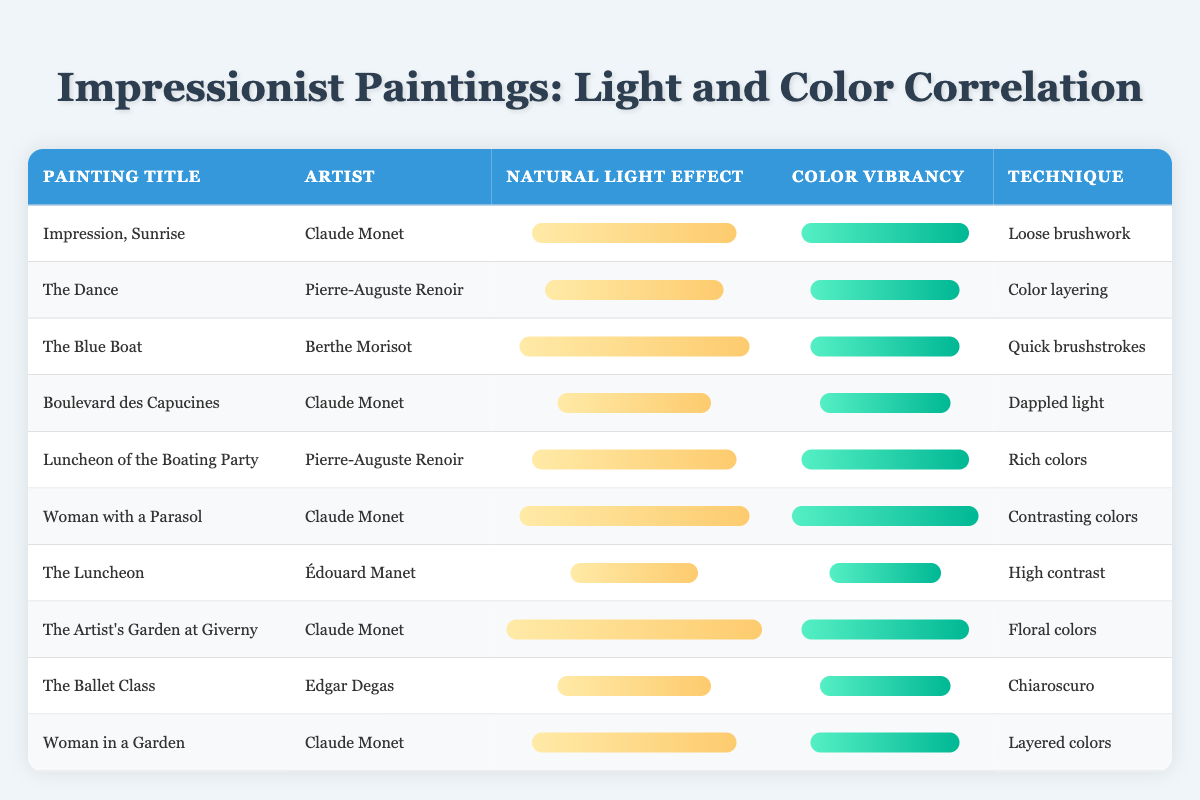What is the natural light effect score for "Woman with a Parasol"? The table lists "Woman with a Parasol" under the painting title column, with a corresponding natural light effect score of 9 in the natural light effect column.
Answer: 9 Which artist created "The Luncheon of the Boating Party"? The artist corresponding to the painting title "Luncheon of the Boating Party" is listed as Pierre-Auguste Renoir in the artist column.
Answer: Pierre-Auguste Renoir How many paintings have a color vibrancy score of 9 or higher? By examining the color vibrancy column, the values of 9 or higher are found in the following paintings: "Impression, Sunrise," "Luncheon of the Boating Party," "Woman with a Parasol," and "The Artist's Garden at Giverny," totaling 4 paintings.
Answer: 4 What is the average natural light effect score of the paintings by Claude Monet? The natural light effect scores for Claude Monet's paintings are: 8, 6, 9, 10, and 8. The sum is 41 (8 + 6 + 9 + 10 + 8) and there are 5 paintings, so the average is 41/5 = 8.2.
Answer: 8.2 Is there a painting with a natural light effect score of 5? Reviewing the natural light effect scores, "The Luncheon" has a score of 5, confirming that there is indeed a painting with this score.
Answer: Yes Which painting has the highest color vibrancy score and what is that score? The painting with the highest color vibrancy score is "Woman with a Parasol," which has a score of 10, as indicated in the color vibrancy column.
Answer: 10 Among the paintings with the lowest natural light effect scores, which one has the highest color vibrancy score? The lowest natural light effect score is 5 (for "The Luncheon"). Among the paintings with scores of 5, 6, or 7, "Boulevard des Capucines" has a color vibrancy score of 7, thus being the highest.
Answer: Boulevard des Capucines What is the difference between the highest and lowest color vibrancy scores in this table? The highest color vibrancy score is 10 (for "Woman with a Parasol") and the lowest is 6 (for "The Luncheon"). The difference is calculated as 10 - 6 = 4.
Answer: 4 How many artists have paintings that scored 6 or lower in natural light effect? The paintings with scores of 6 or lower in natural light effect are "The Luncheon" (5), "Boulevard des Capucines" (6), and "The Ballet Class" (6), corresponding to 3 paintings. Since they are all by different artists, this indicates there are 3 distinct artists.
Answer: 3 